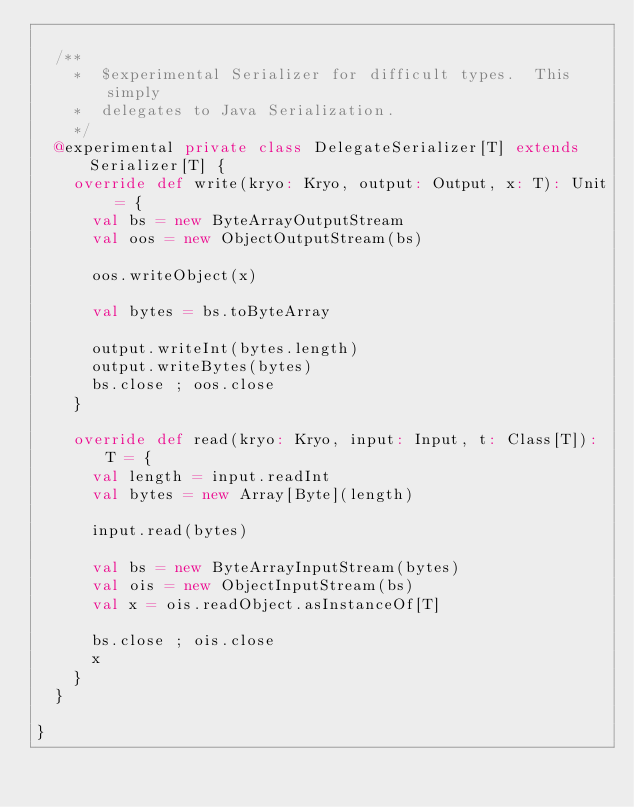Convert code to text. <code><loc_0><loc_0><loc_500><loc_500><_Scala_>
  /**
    *  $experimental Serializer for difficult types.  This simply
    *  delegates to Java Serialization.
    */
  @experimental private class DelegateSerializer[T] extends Serializer[T] {
    override def write(kryo: Kryo, output: Output, x: T): Unit = {
      val bs = new ByteArrayOutputStream
      val oos = new ObjectOutputStream(bs)

      oos.writeObject(x)

      val bytes = bs.toByteArray

      output.writeInt(bytes.length)
      output.writeBytes(bytes)
      bs.close ; oos.close
    }

    override def read(kryo: Kryo, input: Input, t: Class[T]): T = {
      val length = input.readInt
      val bytes = new Array[Byte](length)

      input.read(bytes)

      val bs = new ByteArrayInputStream(bytes)
      val ois = new ObjectInputStream(bs)
      val x = ois.readObject.asInstanceOf[T]

      bs.close ; ois.close
      x
    }
  }

}
</code> 